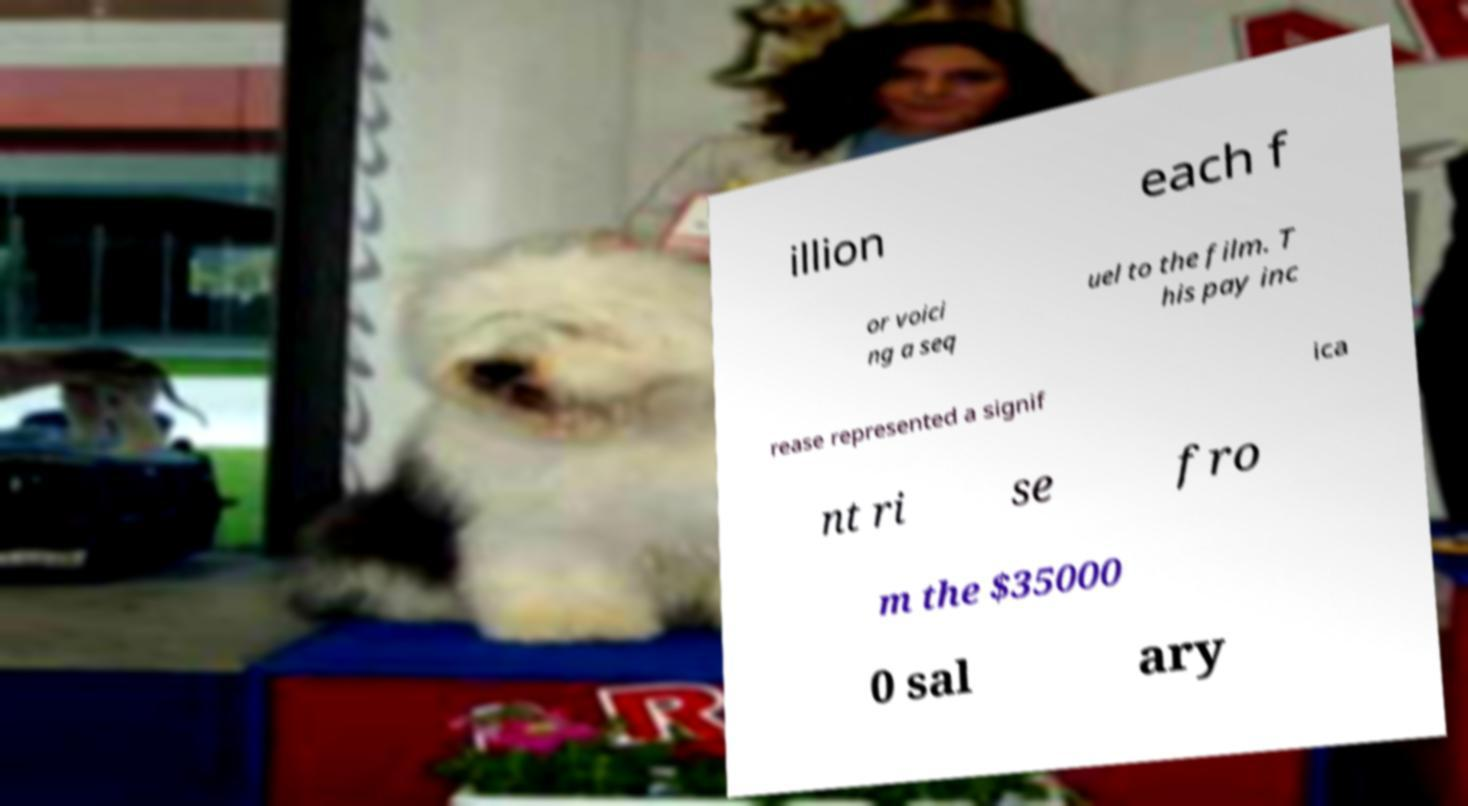There's text embedded in this image that I need extracted. Can you transcribe it verbatim? illion each f or voici ng a seq uel to the film. T his pay inc rease represented a signif ica nt ri se fro m the $35000 0 sal ary 